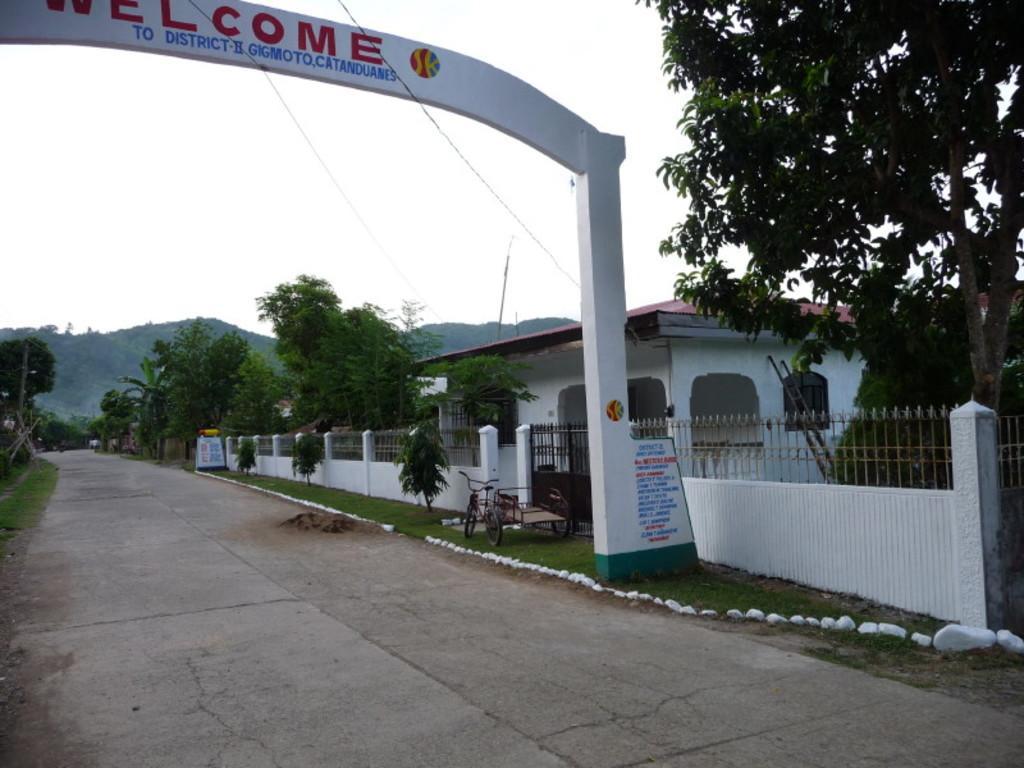In one or two sentences, can you explain what this image depicts? In the left side it is an arch, this is a road in the down side. In the right side it looks like a house, there are trees. 